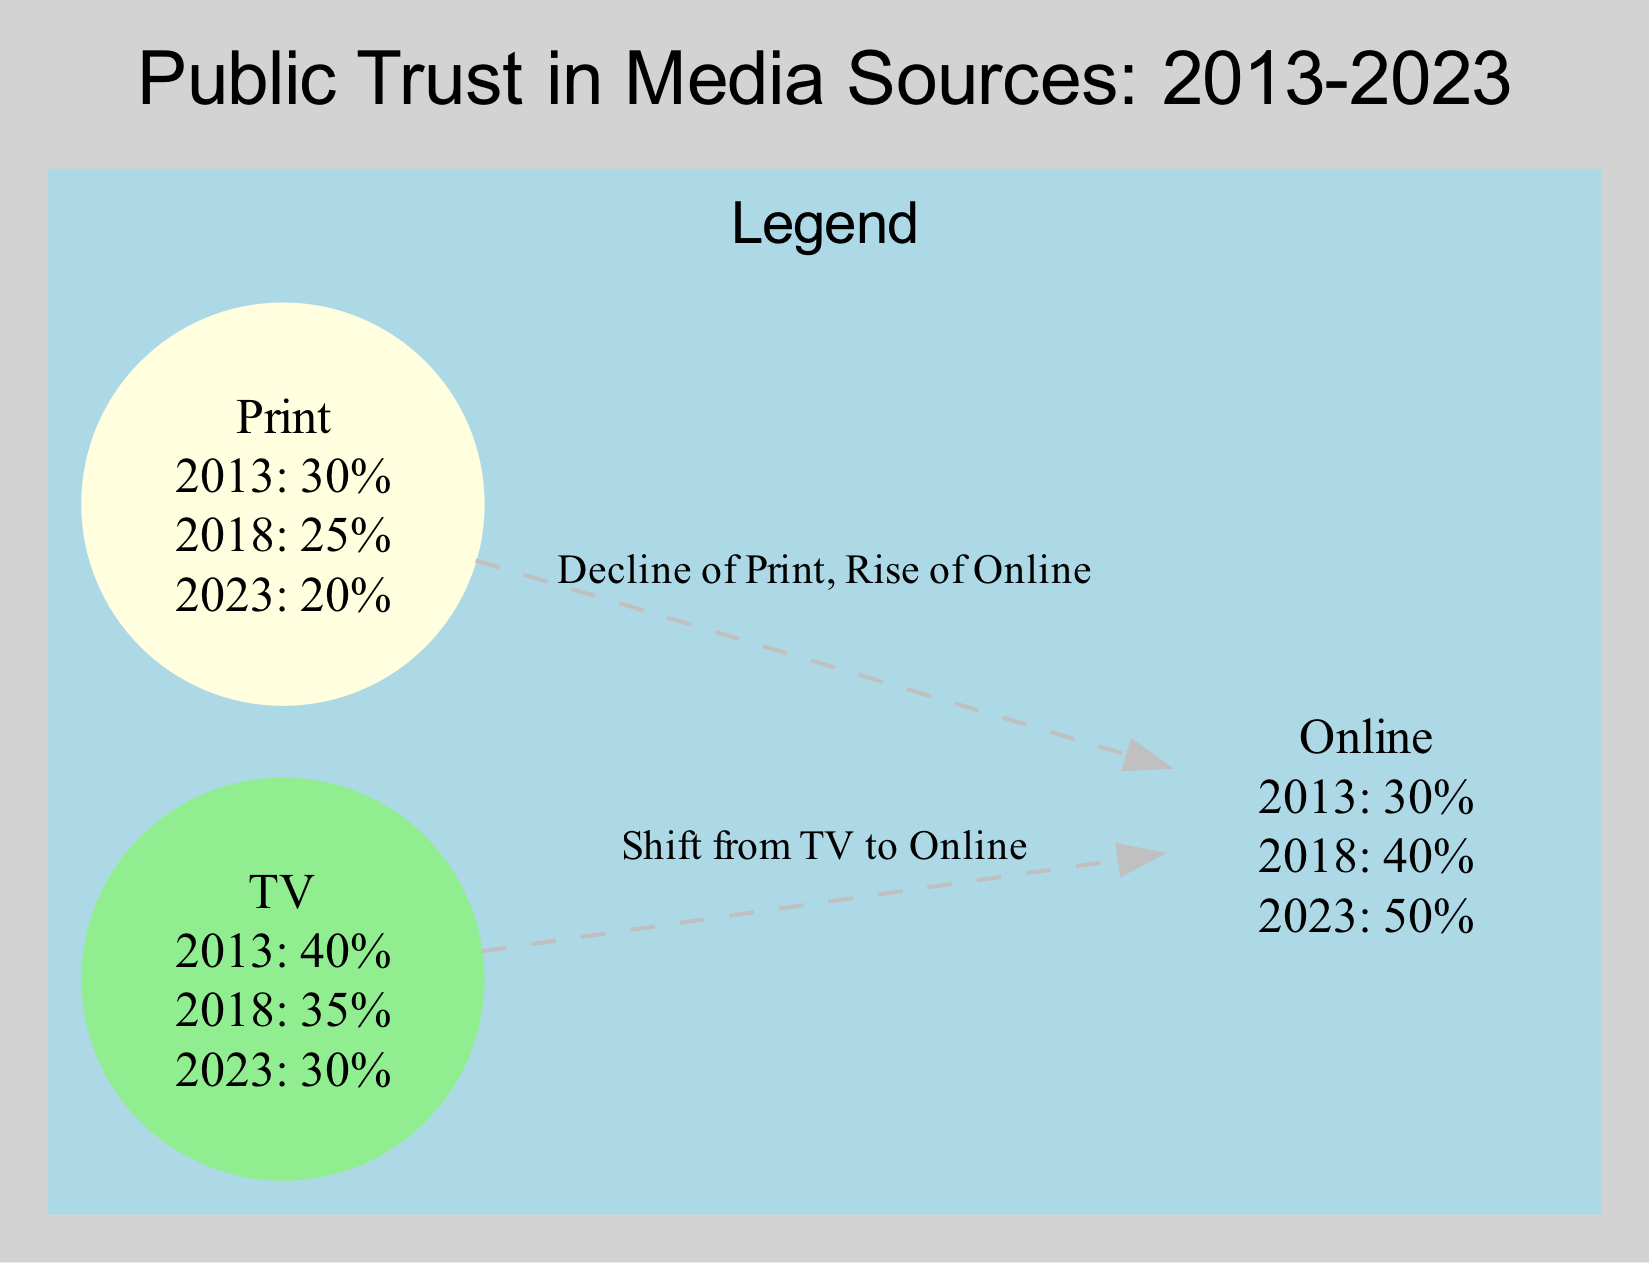What is the trust level in TV media in 2023? The diagram indicates that the trust level in TV media in 2023 is 30%.
Answer: 30% What is the trust level in online media in 2013? According to the data, the trust level in online media in 2013 was 30%.
Answer: 30% Which media format had the highest trust level in 2023? By comparing the trust levels in 2023, online media had the highest trust level at 50%.
Answer: Online What was the trust level decline in print media from 2013 to 2023? In print media, the trust level declined from 30% in 2013 to 20% in 2023, which is a decrease of 10%.
Answer: 10% How many media formats are represented in the diagram? The diagram shows a total of three media formats: TV, online, and print.
Answer: 3 What trend is indicated by the edge labelled "Shift from TV to Online"? The edge indicates a trend reflecting a growing preference for digital content, showing that trust is shifting from TV to online media.
Answer: Growing preference for digital content What is the relationship between print media and online media as described in the edges? The relationship indicates that there is a decline in print media and a simultaneous rise in online media, highlighting the effect of digital transformation in media.
Answer: Decline of Print, Rise of Online What was the trust level in print media in 2018? The diagram indicates that the trust level in print media in 2018 was 25%.
Answer: 25% What was the overall trend in trust levels for TV media from 2013 to 2023? The overall trend for TV media shows a consistent decline in trust levels from 40% in 2013 to 30% in 2023.
Answer: Decline 